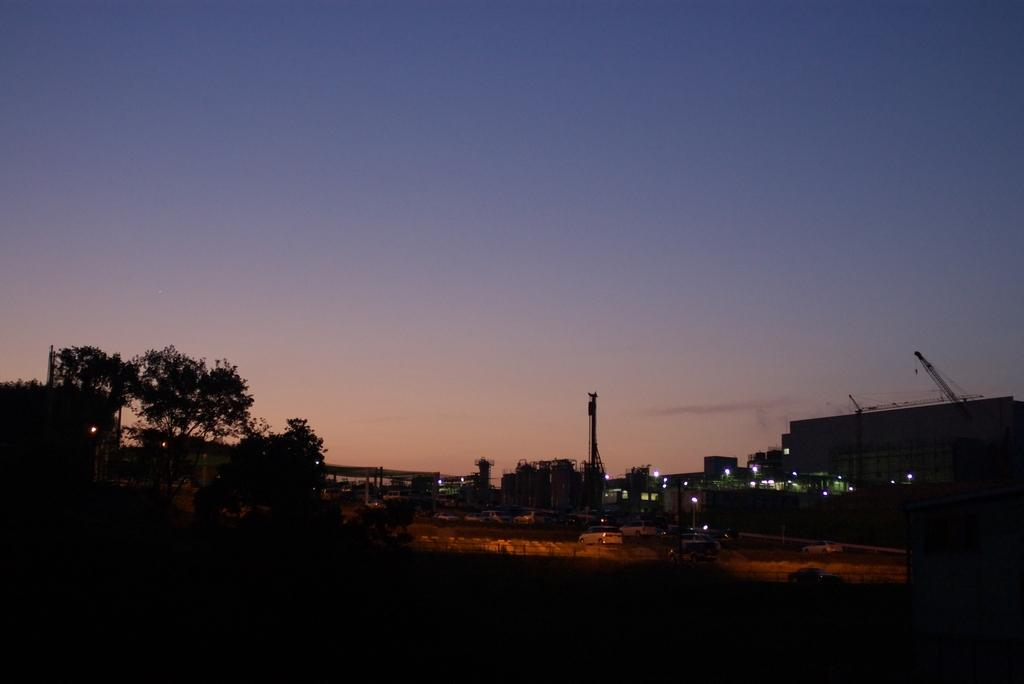What is the setting of the image? The image is a night view of a city. What structures can be seen in the image? There are buildings in the image. What type of lighting is present in the image? Street lights are present in the image. What type of vegetation can be seen in the image? There are trees in the image. What part of the natural environment is visible in the image? The sky is visible in the image. What is the government's desire for the flock of birds in the image? There are no birds present in the image, so it is not possible to determine the government's desire for a flock of birds. 